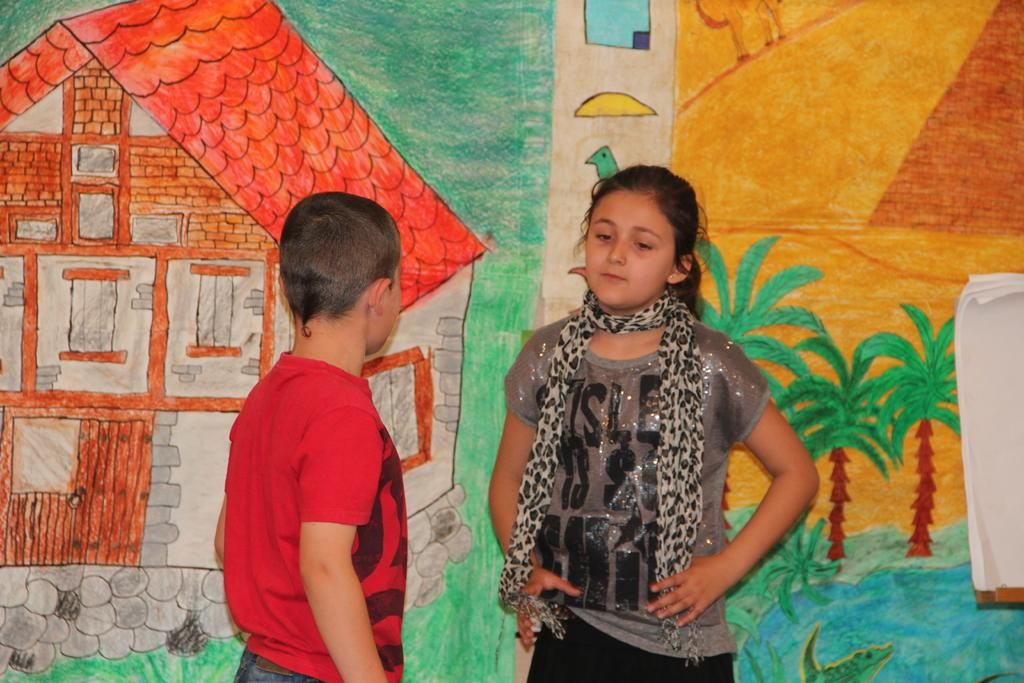How many children are present in the image? There are two children standing in the image. What can be seen on the wall in the image? There are papers attached to the wall, as well as paintings of huts, trees, and birds. Can you describe the paintings on the wall? There are paintings of huts, trees, and birds on the wall. What type of clover can be seen growing on the stove in the image? There is no clover or stove present in the image. What record is being played in the background of the image? There is no record or music playing in the image. 